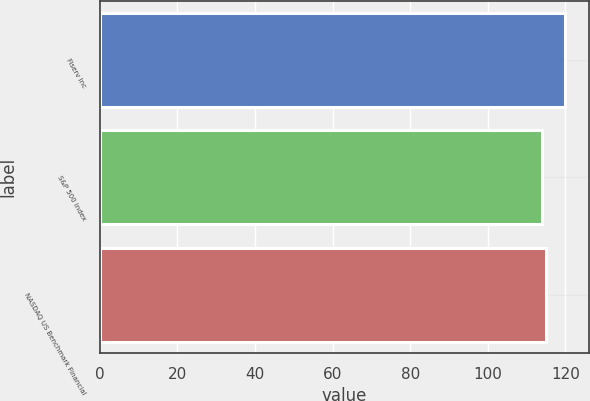Convert chart to OTSL. <chart><loc_0><loc_0><loc_500><loc_500><bar_chart><fcel>Fiserv Inc<fcel>S&P 500 Index<fcel>NASDAQ US Benchmark Financial<nl><fcel>120<fcel>114<fcel>115<nl></chart> 